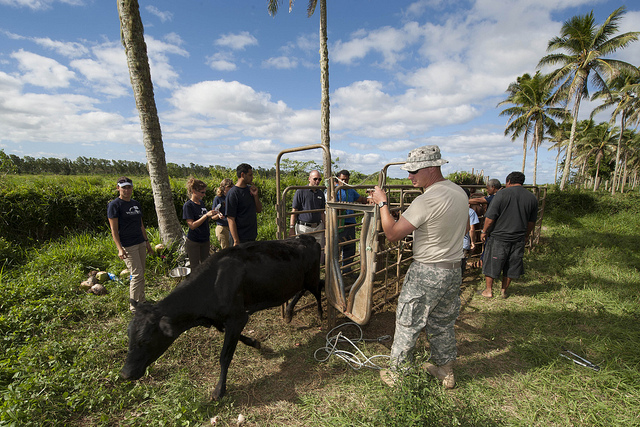<image>What kind of animal is running? I am not sure what kind of animal is running. It can be a cow or a calf. What kind of animal is running? I am not sure what kind of animal is running. But it appears to be a cow. 